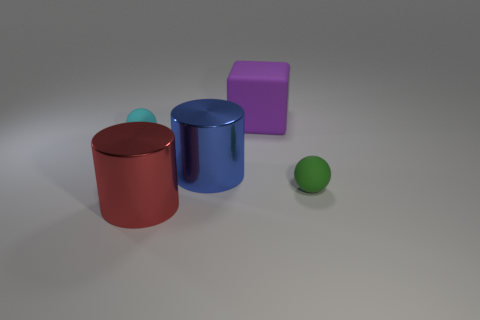Can you describe the positioning of the green sphere in relation to the other objects? The green sphere is positioned to the right of the large blue object and in front of the red cylinder if viewed from the current perspective. 